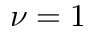<formula> <loc_0><loc_0><loc_500><loc_500>\nu = 1</formula> 